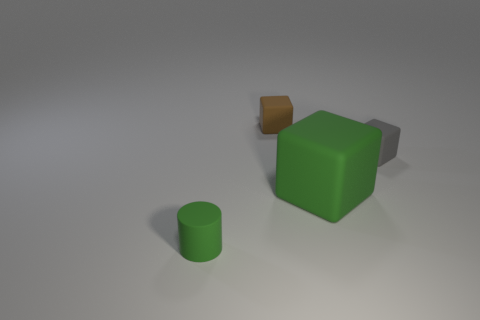Subtract 1 cubes. How many cubes are left? 2 Add 1 large purple matte balls. How many objects exist? 5 Subtract all cylinders. How many objects are left? 3 Add 4 small brown matte objects. How many small brown matte objects are left? 5 Add 4 green things. How many green things exist? 6 Subtract 0 cyan blocks. How many objects are left? 4 Subtract all matte things. Subtract all yellow matte balls. How many objects are left? 0 